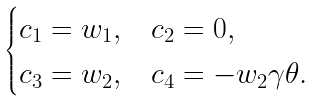<formula> <loc_0><loc_0><loc_500><loc_500>\begin{cases} c _ { 1 } = w _ { 1 } , & c _ { 2 } = 0 , \\ c _ { 3 } = w _ { 2 } , & c _ { 4 } = - w _ { 2 } \gamma \theta . \end{cases}</formula> 